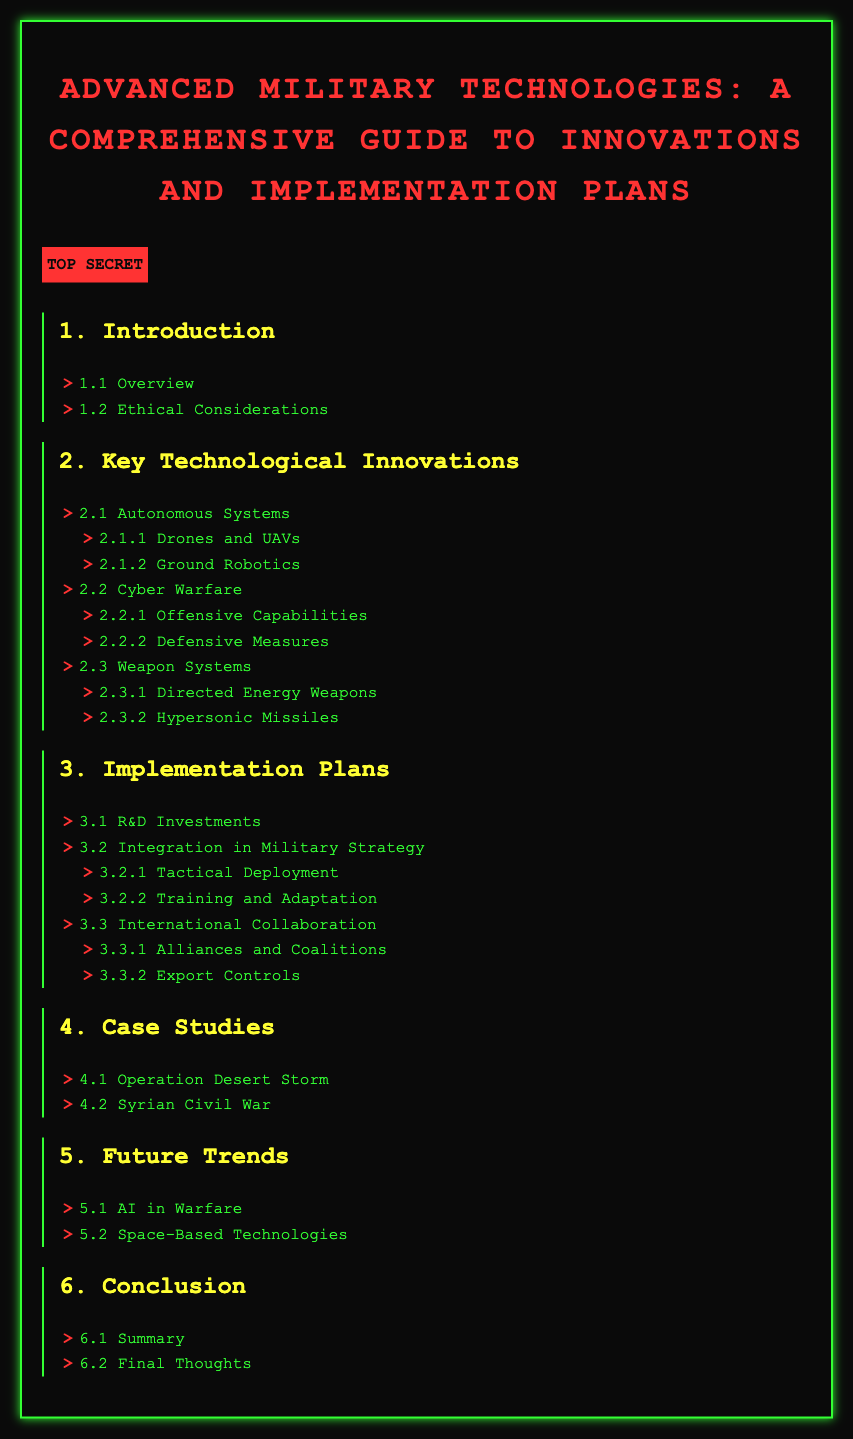What is the title of the document? The title is mentioned at the very beginning of the document and provides a summary of its content.
Answer: Advanced Military Technologies: A Comprehensive Guide to Innovations and Implementation Plans How many sections are in the document? The sections are numbered in the index, contributing to the total count of sections which can be seen in the list.
Answer: 6 Which section discusses Ethical Considerations? The index clearly outlines the sections and sub-sections, leading to the specific topic in question.
Answer: 1.2 Ethical Considerations What are the two categories under Cyber Warfare? Each section lists its subcategories to give detailed information regarding the subtopics covered within it.
Answer: Offensive Capabilities, Defensive Measures Which operation is highlighted in the Case Studies section? The case studies section lists specific military operations as examples of technological application in warfare.
Answer: Operation Desert Storm What is one future trend discussed in the document? The future trends section explicitly lists upcoming innovations or shifts in military technology expected in time.
Answer: AI in Warfare 